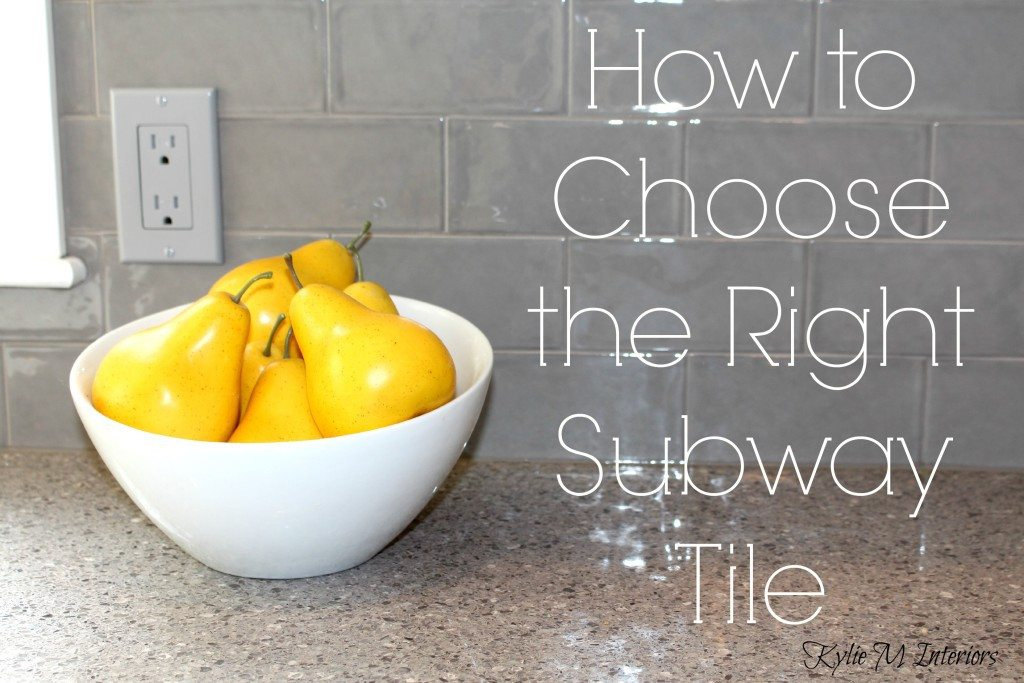Considering the design elements visible in the image, what might be the implications of choosing a subway tile of this particular color and finish for the lighting and perceived spaciousness of the kitchen? The glossy finish of the gray subway tiles reflects light, which can contribute to a brighter kitchen when illuminated. This reflective property may enhance the sense of space, making the kitchen feel larger and more open. The neutral color of the tiles also allows for versatile color coordination with other kitchen elements, such as the countertops and appliances, and can contribute to a timeless aesthetic that complements various design trends over time. 